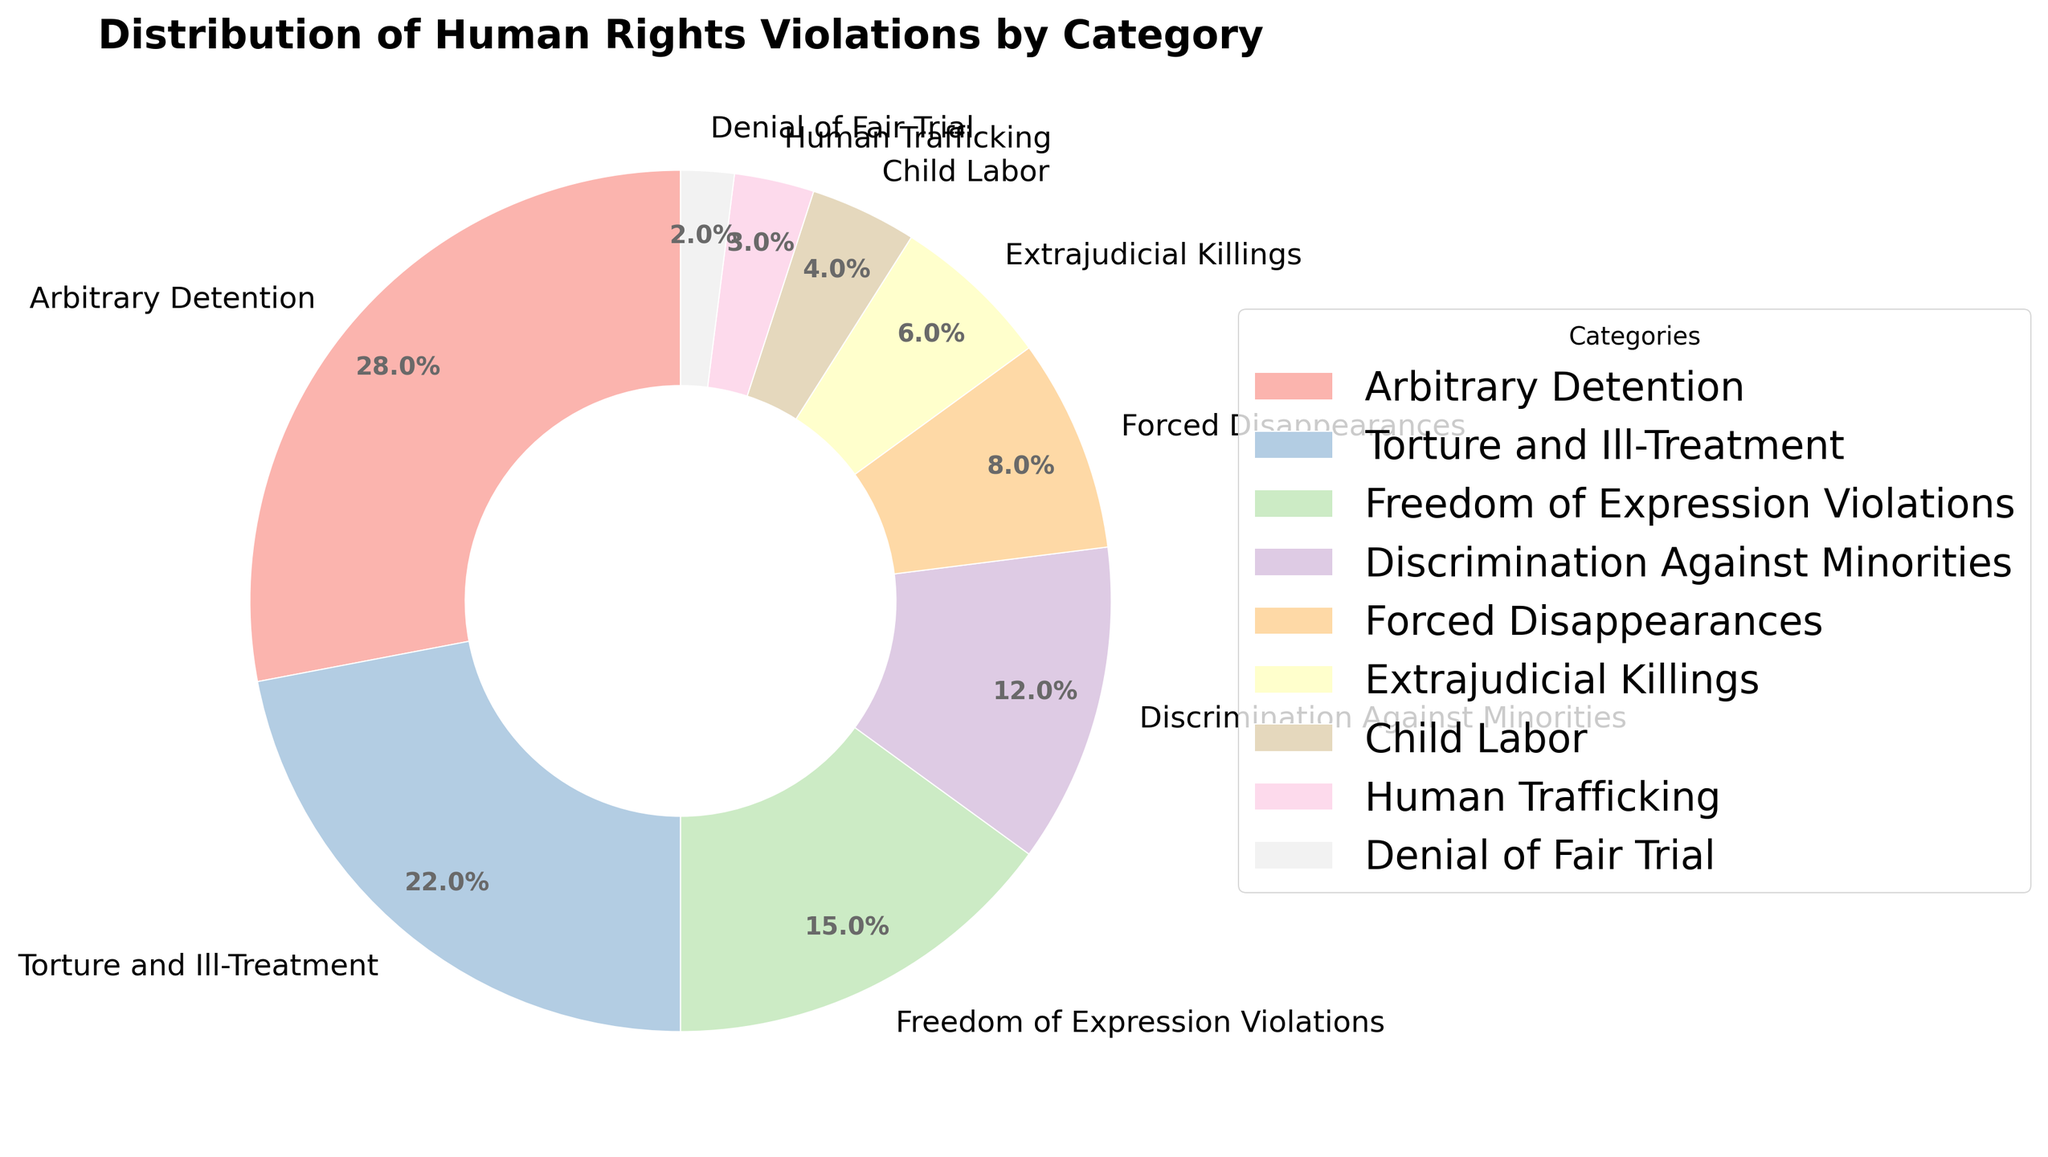Which category accounts for the largest percentage of human rights violations? The chart shows that "Arbitrary Detention" has the largest wedge, which corresponds to 28%.
Answer: Arbitrary Detention Which category accounts for the smallest percentage of human rights violations? The smallest wedge in the chart represents "Denial of Fair Trial" at 2%.
Answer: Denial of Fair Trial What is the difference in the percentage between "Arbitrary Detention" and "Torture and Ill-Treatment"? "Arbitrary Detention" has 28%, and "Torture and Ill-Treatment" has 22%. The difference is 28% - 22% = 6%.
Answer: 6% What percentage of human rights violations is accounted for by "Discrimination Against Minorities" and "Freedom of Expression Violations" combined? "Discrimination Against Minorities" is 12% and "Freedom of Expression Violations" is 15%. Combined, they account for 12% + 15% = 27%.
Answer: 27% Are "Child Labor" and "Human Trafficking" together less than "Forced Disappearances"? "Child Labor" is 4%, and "Human Trafficking" is 3%, so together they make 4% + 3% = 7%. "Forced Disappearances" is 8%, which is greater than 7%.
Answer: Yes How many categories account for 10% or more of the human rights violations? "Arbitrary Detention" (28%), "Torture and Ill-Treatment" (22%), and "Freedom of Expression Violations" (15%), "Discrimination Against Minorities" (12%) all account for 10% or more. There are 4 such categories.
Answer: 4 Is the percentage of "Extrajudicial Killings" more than twice that of "Denial of Fair Trial"? "Extrajudicial Killings" is 6% and "Denial of Fair Trial" is 2%. Twice "Denial of Fair Trial" is 2% * 2 = 4%. Since 6% > 4%, "Extrajudicial Killings" is more than twice.
Answer: Yes What is the average percentage of the categories with less than 10%? The categories are "Forced Disappearances" (8%), "Extrajudicial Killings" (6%), "Child Labor" (4%), "Human Trafficking" (3%), and "Denial of Fair Trial" (2%). The average is (8% + 6% + 4% + 3% + 2%) / 5 = 23% / 5 = 4.6%.
Answer: 4.6% Which category is represented by the darkest color in the chart? The chart uses colors to differentiate categories, with the darkest color representing "Arbitrary Detention". This is common in color schemes where higher values are more prominent.
Answer: Arbitrary Detention 